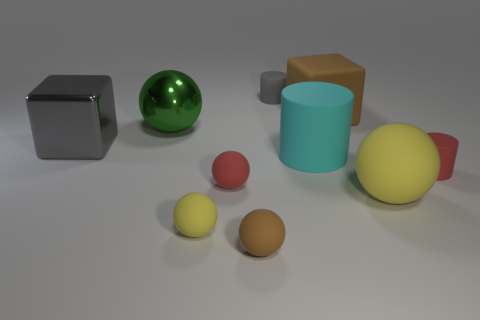There is a gray thing that is the same size as the green metallic ball; what is its shape?
Keep it short and to the point. Cube. Are there any green metallic balls behind the large metal sphere?
Offer a terse response. No. There is a brown rubber object that is in front of the large gray block; are there any brown things that are in front of it?
Make the answer very short. No. Is the number of small gray objects that are in front of the brown matte ball less than the number of tiny yellow balls that are behind the green thing?
Your response must be concise. No. Are there any other things that are the same size as the cyan object?
Offer a very short reply. Yes. What is the shape of the small brown object?
Ensure brevity in your answer.  Sphere. What material is the big block that is in front of the green metallic ball?
Make the answer very short. Metal. What size is the brown thing that is in front of the small thing that is on the right side of the yellow sphere on the right side of the brown block?
Your answer should be very brief. Small. Are the small brown object that is to the left of the big matte cylinder and the large cube to the right of the tiny yellow thing made of the same material?
Make the answer very short. Yes. What number of other things are the same color as the big metal cube?
Give a very brief answer. 1. 